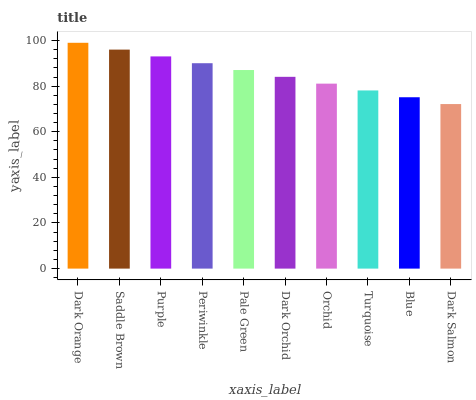Is Dark Salmon the minimum?
Answer yes or no. Yes. Is Dark Orange the maximum?
Answer yes or no. Yes. Is Saddle Brown the minimum?
Answer yes or no. No. Is Saddle Brown the maximum?
Answer yes or no. No. Is Dark Orange greater than Saddle Brown?
Answer yes or no. Yes. Is Saddle Brown less than Dark Orange?
Answer yes or no. Yes. Is Saddle Brown greater than Dark Orange?
Answer yes or no. No. Is Dark Orange less than Saddle Brown?
Answer yes or no. No. Is Pale Green the high median?
Answer yes or no. Yes. Is Dark Orchid the low median?
Answer yes or no. Yes. Is Saddle Brown the high median?
Answer yes or no. No. Is Turquoise the low median?
Answer yes or no. No. 